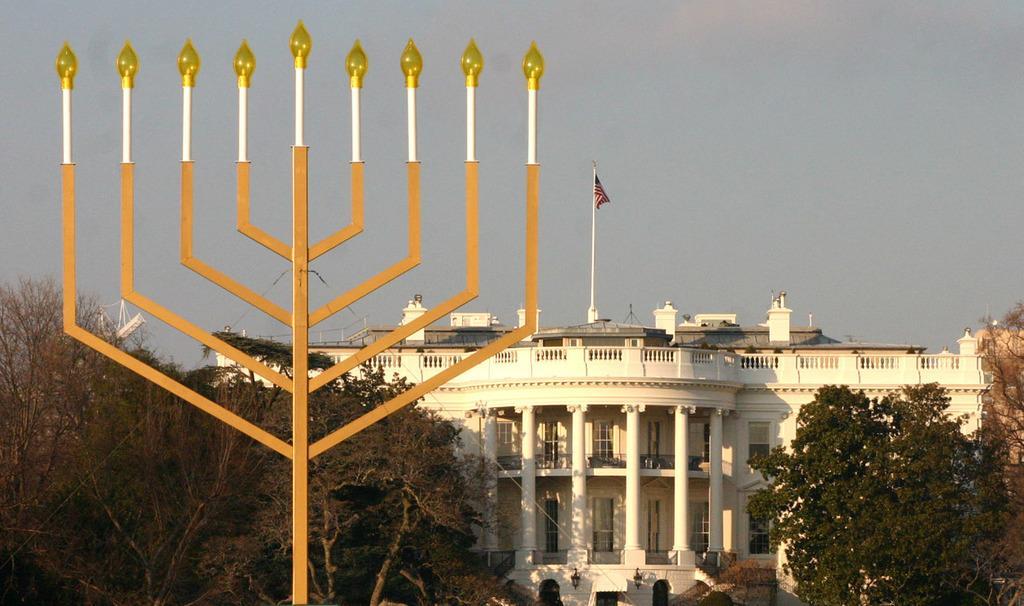In one or two sentences, can you explain what this image depicts? In this picture we can see a building, in the front there are some lights, we can see trees here, there is the sky at the top of the picture, we can see a flag here. 